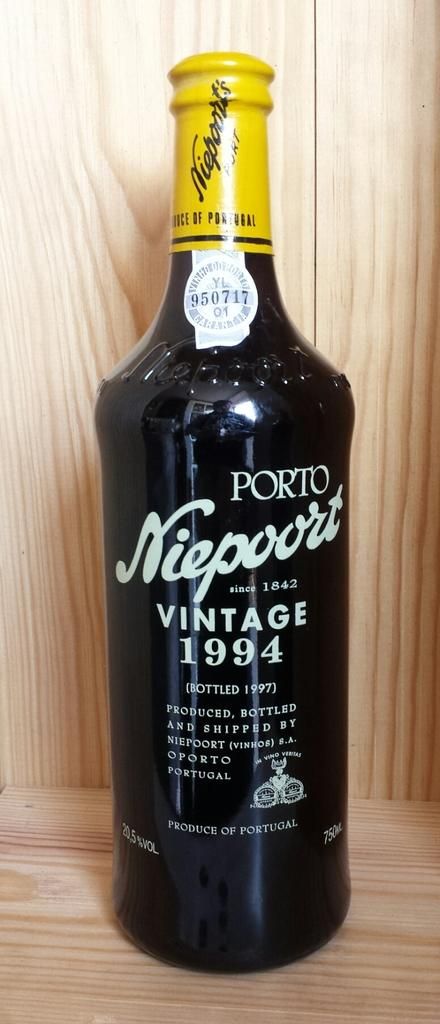Provide a one-sentence caption for the provided image. A bottle of alcohol made by porto niepoort says vintage 1994 on it. 